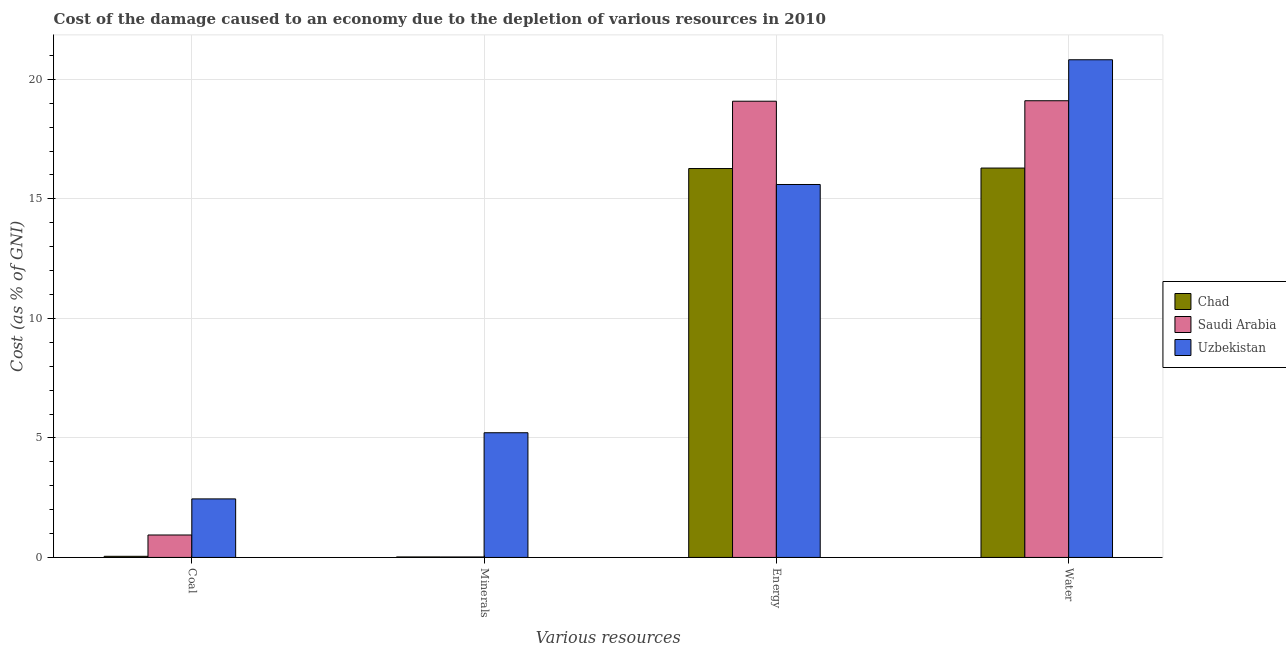Are the number of bars per tick equal to the number of legend labels?
Your response must be concise. Yes. Are the number of bars on each tick of the X-axis equal?
Give a very brief answer. Yes. What is the label of the 4th group of bars from the left?
Your response must be concise. Water. What is the cost of damage due to depletion of energy in Saudi Arabia?
Ensure brevity in your answer.  19.09. Across all countries, what is the maximum cost of damage due to depletion of water?
Ensure brevity in your answer.  20.82. Across all countries, what is the minimum cost of damage due to depletion of coal?
Make the answer very short. 0.05. In which country was the cost of damage due to depletion of coal maximum?
Make the answer very short. Uzbekistan. In which country was the cost of damage due to depletion of energy minimum?
Keep it short and to the point. Uzbekistan. What is the total cost of damage due to depletion of water in the graph?
Provide a short and direct response. 56.22. What is the difference between the cost of damage due to depletion of energy in Uzbekistan and that in Chad?
Offer a very short reply. -0.67. What is the difference between the cost of damage due to depletion of coal in Saudi Arabia and the cost of damage due to depletion of minerals in Uzbekistan?
Your response must be concise. -4.28. What is the average cost of damage due to depletion of minerals per country?
Provide a short and direct response. 1.75. What is the difference between the cost of damage due to depletion of water and cost of damage due to depletion of minerals in Uzbekistan?
Provide a succinct answer. 15.6. In how many countries, is the cost of damage due to depletion of coal greater than 7 %?
Your answer should be very brief. 0. What is the ratio of the cost of damage due to depletion of water in Chad to that in Saudi Arabia?
Keep it short and to the point. 0.85. Is the cost of damage due to depletion of water in Chad less than that in Saudi Arabia?
Ensure brevity in your answer.  Yes. What is the difference between the highest and the second highest cost of damage due to depletion of minerals?
Offer a terse response. 5.2. What is the difference between the highest and the lowest cost of damage due to depletion of minerals?
Your answer should be compact. 5.2. In how many countries, is the cost of damage due to depletion of energy greater than the average cost of damage due to depletion of energy taken over all countries?
Keep it short and to the point. 1. Is the sum of the cost of damage due to depletion of energy in Chad and Saudi Arabia greater than the maximum cost of damage due to depletion of water across all countries?
Your answer should be compact. Yes. Is it the case that in every country, the sum of the cost of damage due to depletion of water and cost of damage due to depletion of coal is greater than the sum of cost of damage due to depletion of minerals and cost of damage due to depletion of energy?
Your answer should be compact. Yes. What does the 2nd bar from the left in Energy represents?
Provide a succinct answer. Saudi Arabia. What does the 3rd bar from the right in Energy represents?
Ensure brevity in your answer.  Chad. How many countries are there in the graph?
Ensure brevity in your answer.  3. What is the difference between two consecutive major ticks on the Y-axis?
Your answer should be very brief. 5. Does the graph contain any zero values?
Your answer should be very brief. No. Does the graph contain grids?
Keep it short and to the point. Yes. Where does the legend appear in the graph?
Make the answer very short. Center right. What is the title of the graph?
Offer a terse response. Cost of the damage caused to an economy due to the depletion of various resources in 2010 . What is the label or title of the X-axis?
Keep it short and to the point. Various resources. What is the label or title of the Y-axis?
Give a very brief answer. Cost (as % of GNI). What is the Cost (as % of GNI) of Chad in Coal?
Your answer should be very brief. 0.05. What is the Cost (as % of GNI) of Saudi Arabia in Coal?
Offer a terse response. 0.94. What is the Cost (as % of GNI) in Uzbekistan in Coal?
Offer a terse response. 2.45. What is the Cost (as % of GNI) in Chad in Minerals?
Ensure brevity in your answer.  0.02. What is the Cost (as % of GNI) of Saudi Arabia in Minerals?
Your answer should be compact. 0.02. What is the Cost (as % of GNI) of Uzbekistan in Minerals?
Provide a short and direct response. 5.22. What is the Cost (as % of GNI) in Chad in Energy?
Keep it short and to the point. 16.27. What is the Cost (as % of GNI) in Saudi Arabia in Energy?
Make the answer very short. 19.09. What is the Cost (as % of GNI) in Uzbekistan in Energy?
Keep it short and to the point. 15.6. What is the Cost (as % of GNI) in Chad in Water?
Provide a short and direct response. 16.29. What is the Cost (as % of GNI) of Saudi Arabia in Water?
Offer a very short reply. 19.11. What is the Cost (as % of GNI) in Uzbekistan in Water?
Your response must be concise. 20.82. Across all Various resources, what is the maximum Cost (as % of GNI) in Chad?
Ensure brevity in your answer.  16.29. Across all Various resources, what is the maximum Cost (as % of GNI) of Saudi Arabia?
Offer a terse response. 19.11. Across all Various resources, what is the maximum Cost (as % of GNI) of Uzbekistan?
Make the answer very short. 20.82. Across all Various resources, what is the minimum Cost (as % of GNI) in Chad?
Your answer should be very brief. 0.02. Across all Various resources, what is the minimum Cost (as % of GNI) of Saudi Arabia?
Your answer should be very brief. 0.02. Across all Various resources, what is the minimum Cost (as % of GNI) of Uzbekistan?
Offer a very short reply. 2.45. What is the total Cost (as % of GNI) in Chad in the graph?
Offer a very short reply. 32.63. What is the total Cost (as % of GNI) in Saudi Arabia in the graph?
Offer a terse response. 39.15. What is the total Cost (as % of GNI) in Uzbekistan in the graph?
Your answer should be compact. 44.09. What is the difference between the Cost (as % of GNI) of Chad in Coal and that in Minerals?
Provide a short and direct response. 0.03. What is the difference between the Cost (as % of GNI) of Saudi Arabia in Coal and that in Minerals?
Give a very brief answer. 0.92. What is the difference between the Cost (as % of GNI) in Uzbekistan in Coal and that in Minerals?
Your answer should be compact. -2.77. What is the difference between the Cost (as % of GNI) in Chad in Coal and that in Energy?
Make the answer very short. -16.22. What is the difference between the Cost (as % of GNI) of Saudi Arabia in Coal and that in Energy?
Make the answer very short. -18.15. What is the difference between the Cost (as % of GNI) in Uzbekistan in Coal and that in Energy?
Offer a terse response. -13.15. What is the difference between the Cost (as % of GNI) in Chad in Coal and that in Water?
Ensure brevity in your answer.  -16.24. What is the difference between the Cost (as % of GNI) in Saudi Arabia in Coal and that in Water?
Your answer should be very brief. -18.17. What is the difference between the Cost (as % of GNI) in Uzbekistan in Coal and that in Water?
Your answer should be compact. -18.37. What is the difference between the Cost (as % of GNI) of Chad in Minerals and that in Energy?
Your answer should be compact. -16.25. What is the difference between the Cost (as % of GNI) of Saudi Arabia in Minerals and that in Energy?
Your response must be concise. -19.07. What is the difference between the Cost (as % of GNI) in Uzbekistan in Minerals and that in Energy?
Offer a terse response. -10.39. What is the difference between the Cost (as % of GNI) of Chad in Minerals and that in Water?
Ensure brevity in your answer.  -16.27. What is the difference between the Cost (as % of GNI) of Saudi Arabia in Minerals and that in Water?
Ensure brevity in your answer.  -19.09. What is the difference between the Cost (as % of GNI) of Uzbekistan in Minerals and that in Water?
Your response must be concise. -15.6. What is the difference between the Cost (as % of GNI) of Chad in Energy and that in Water?
Give a very brief answer. -0.02. What is the difference between the Cost (as % of GNI) in Saudi Arabia in Energy and that in Water?
Keep it short and to the point. -0.02. What is the difference between the Cost (as % of GNI) of Uzbekistan in Energy and that in Water?
Make the answer very short. -5.22. What is the difference between the Cost (as % of GNI) in Chad in Coal and the Cost (as % of GNI) in Saudi Arabia in Minerals?
Your answer should be very brief. 0.03. What is the difference between the Cost (as % of GNI) of Chad in Coal and the Cost (as % of GNI) of Uzbekistan in Minerals?
Offer a very short reply. -5.17. What is the difference between the Cost (as % of GNI) of Saudi Arabia in Coal and the Cost (as % of GNI) of Uzbekistan in Minerals?
Provide a succinct answer. -4.28. What is the difference between the Cost (as % of GNI) in Chad in Coal and the Cost (as % of GNI) in Saudi Arabia in Energy?
Keep it short and to the point. -19.04. What is the difference between the Cost (as % of GNI) in Chad in Coal and the Cost (as % of GNI) in Uzbekistan in Energy?
Offer a very short reply. -15.56. What is the difference between the Cost (as % of GNI) in Saudi Arabia in Coal and the Cost (as % of GNI) in Uzbekistan in Energy?
Provide a succinct answer. -14.66. What is the difference between the Cost (as % of GNI) in Chad in Coal and the Cost (as % of GNI) in Saudi Arabia in Water?
Keep it short and to the point. -19.06. What is the difference between the Cost (as % of GNI) in Chad in Coal and the Cost (as % of GNI) in Uzbekistan in Water?
Give a very brief answer. -20.77. What is the difference between the Cost (as % of GNI) of Saudi Arabia in Coal and the Cost (as % of GNI) of Uzbekistan in Water?
Your response must be concise. -19.88. What is the difference between the Cost (as % of GNI) in Chad in Minerals and the Cost (as % of GNI) in Saudi Arabia in Energy?
Your answer should be compact. -19.07. What is the difference between the Cost (as % of GNI) of Chad in Minerals and the Cost (as % of GNI) of Uzbekistan in Energy?
Your response must be concise. -15.58. What is the difference between the Cost (as % of GNI) of Saudi Arabia in Minerals and the Cost (as % of GNI) of Uzbekistan in Energy?
Provide a short and direct response. -15.58. What is the difference between the Cost (as % of GNI) of Chad in Minerals and the Cost (as % of GNI) of Saudi Arabia in Water?
Offer a very short reply. -19.09. What is the difference between the Cost (as % of GNI) of Chad in Minerals and the Cost (as % of GNI) of Uzbekistan in Water?
Provide a succinct answer. -20.8. What is the difference between the Cost (as % of GNI) in Saudi Arabia in Minerals and the Cost (as % of GNI) in Uzbekistan in Water?
Provide a succinct answer. -20.8. What is the difference between the Cost (as % of GNI) in Chad in Energy and the Cost (as % of GNI) in Saudi Arabia in Water?
Offer a very short reply. -2.84. What is the difference between the Cost (as % of GNI) of Chad in Energy and the Cost (as % of GNI) of Uzbekistan in Water?
Give a very brief answer. -4.55. What is the difference between the Cost (as % of GNI) in Saudi Arabia in Energy and the Cost (as % of GNI) in Uzbekistan in Water?
Give a very brief answer. -1.73. What is the average Cost (as % of GNI) in Chad per Various resources?
Offer a terse response. 8.16. What is the average Cost (as % of GNI) in Saudi Arabia per Various resources?
Offer a very short reply. 9.79. What is the average Cost (as % of GNI) of Uzbekistan per Various resources?
Your answer should be very brief. 11.02. What is the difference between the Cost (as % of GNI) in Chad and Cost (as % of GNI) in Saudi Arabia in Coal?
Provide a short and direct response. -0.89. What is the difference between the Cost (as % of GNI) in Chad and Cost (as % of GNI) in Uzbekistan in Coal?
Your answer should be very brief. -2.4. What is the difference between the Cost (as % of GNI) of Saudi Arabia and Cost (as % of GNI) of Uzbekistan in Coal?
Keep it short and to the point. -1.51. What is the difference between the Cost (as % of GNI) in Chad and Cost (as % of GNI) in Saudi Arabia in Minerals?
Provide a succinct answer. 0. What is the difference between the Cost (as % of GNI) of Chad and Cost (as % of GNI) of Uzbekistan in Minerals?
Provide a short and direct response. -5.2. What is the difference between the Cost (as % of GNI) of Saudi Arabia and Cost (as % of GNI) of Uzbekistan in Minerals?
Ensure brevity in your answer.  -5.2. What is the difference between the Cost (as % of GNI) in Chad and Cost (as % of GNI) in Saudi Arabia in Energy?
Your answer should be very brief. -2.82. What is the difference between the Cost (as % of GNI) of Chad and Cost (as % of GNI) of Uzbekistan in Energy?
Your response must be concise. 0.67. What is the difference between the Cost (as % of GNI) in Saudi Arabia and Cost (as % of GNI) in Uzbekistan in Energy?
Give a very brief answer. 3.48. What is the difference between the Cost (as % of GNI) in Chad and Cost (as % of GNI) in Saudi Arabia in Water?
Keep it short and to the point. -2.82. What is the difference between the Cost (as % of GNI) of Chad and Cost (as % of GNI) of Uzbekistan in Water?
Provide a succinct answer. -4.53. What is the difference between the Cost (as % of GNI) in Saudi Arabia and Cost (as % of GNI) in Uzbekistan in Water?
Provide a short and direct response. -1.71. What is the ratio of the Cost (as % of GNI) of Chad in Coal to that in Minerals?
Provide a succinct answer. 2.35. What is the ratio of the Cost (as % of GNI) of Saudi Arabia in Coal to that in Minerals?
Keep it short and to the point. 49.11. What is the ratio of the Cost (as % of GNI) of Uzbekistan in Coal to that in Minerals?
Provide a short and direct response. 0.47. What is the ratio of the Cost (as % of GNI) of Chad in Coal to that in Energy?
Ensure brevity in your answer.  0. What is the ratio of the Cost (as % of GNI) of Saudi Arabia in Coal to that in Energy?
Make the answer very short. 0.05. What is the ratio of the Cost (as % of GNI) in Uzbekistan in Coal to that in Energy?
Your answer should be compact. 0.16. What is the ratio of the Cost (as % of GNI) in Chad in Coal to that in Water?
Your answer should be compact. 0. What is the ratio of the Cost (as % of GNI) in Saudi Arabia in Coal to that in Water?
Keep it short and to the point. 0.05. What is the ratio of the Cost (as % of GNI) of Uzbekistan in Coal to that in Water?
Make the answer very short. 0.12. What is the ratio of the Cost (as % of GNI) of Chad in Minerals to that in Energy?
Keep it short and to the point. 0. What is the ratio of the Cost (as % of GNI) of Saudi Arabia in Minerals to that in Energy?
Your response must be concise. 0. What is the ratio of the Cost (as % of GNI) of Uzbekistan in Minerals to that in Energy?
Your answer should be very brief. 0.33. What is the ratio of the Cost (as % of GNI) in Chad in Minerals to that in Water?
Provide a succinct answer. 0. What is the ratio of the Cost (as % of GNI) in Uzbekistan in Minerals to that in Water?
Offer a terse response. 0.25. What is the ratio of the Cost (as % of GNI) in Saudi Arabia in Energy to that in Water?
Offer a very short reply. 1. What is the ratio of the Cost (as % of GNI) in Uzbekistan in Energy to that in Water?
Give a very brief answer. 0.75. What is the difference between the highest and the second highest Cost (as % of GNI) in Saudi Arabia?
Make the answer very short. 0.02. What is the difference between the highest and the second highest Cost (as % of GNI) in Uzbekistan?
Provide a short and direct response. 5.22. What is the difference between the highest and the lowest Cost (as % of GNI) in Chad?
Make the answer very short. 16.27. What is the difference between the highest and the lowest Cost (as % of GNI) of Saudi Arabia?
Provide a short and direct response. 19.09. What is the difference between the highest and the lowest Cost (as % of GNI) in Uzbekistan?
Your answer should be very brief. 18.37. 